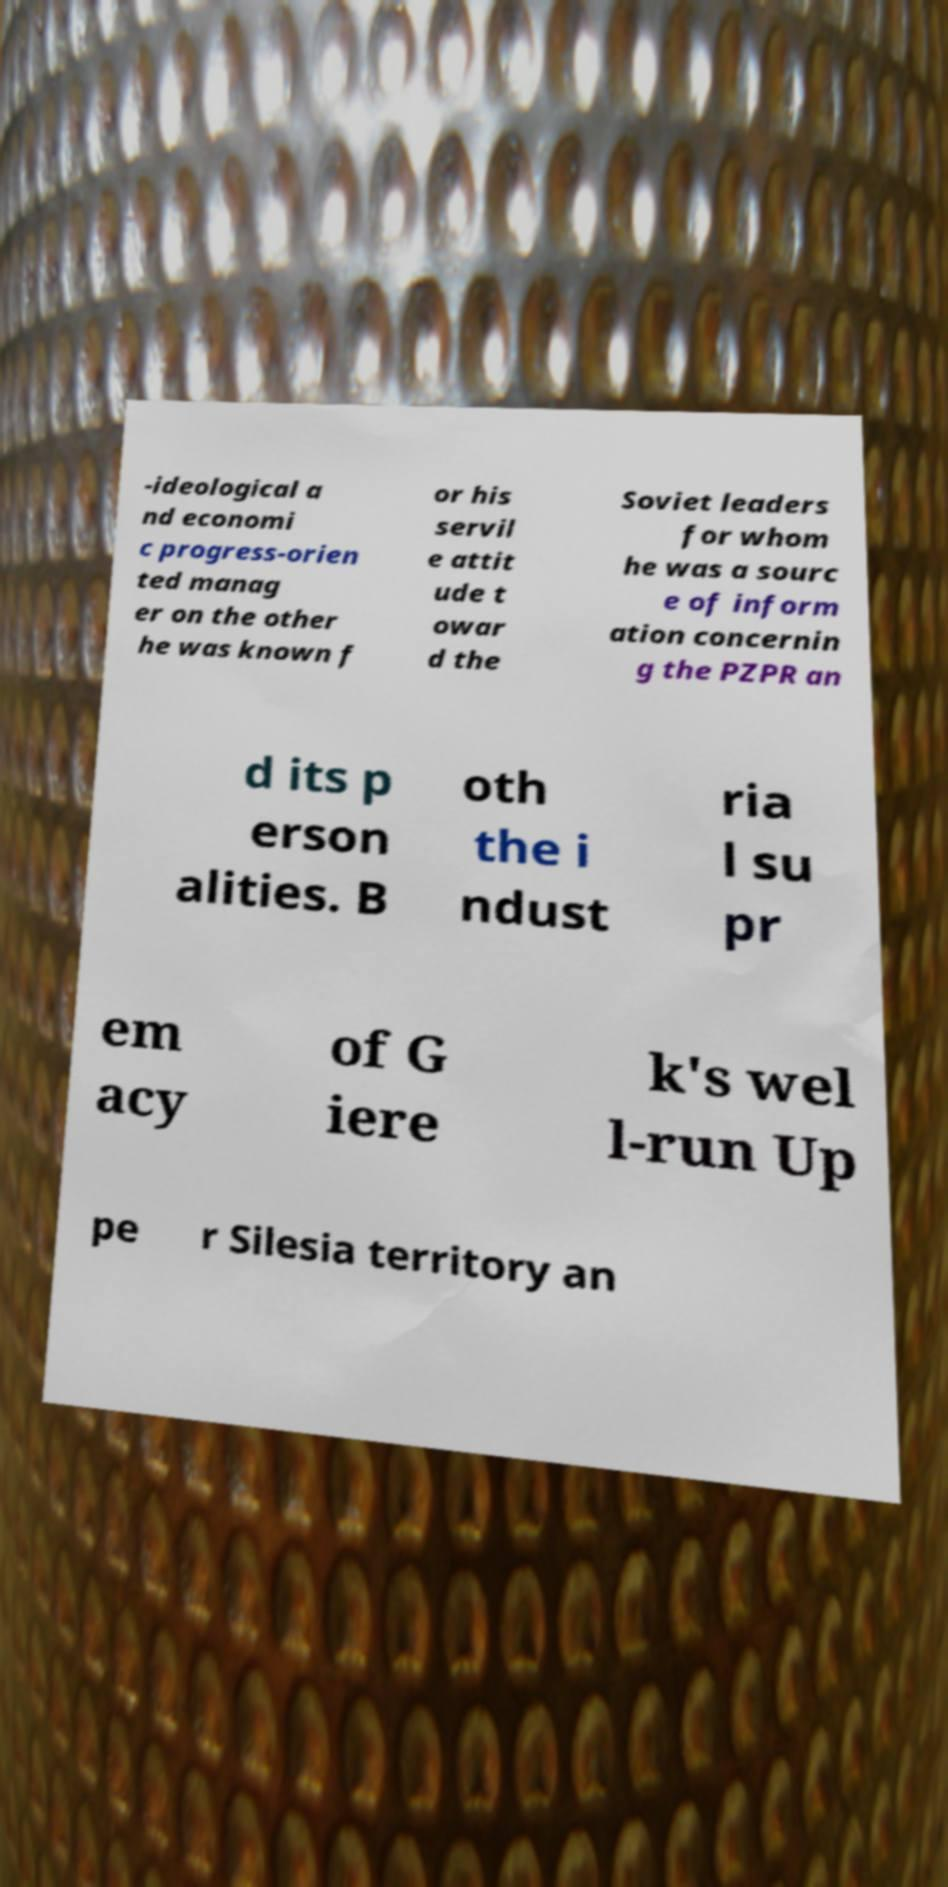What messages or text are displayed in this image? I need them in a readable, typed format. -ideological a nd economi c progress-orien ted manag er on the other he was known f or his servil e attit ude t owar d the Soviet leaders for whom he was a sourc e of inform ation concernin g the PZPR an d its p erson alities. B oth the i ndust ria l su pr em acy of G iere k's wel l-run Up pe r Silesia territory an 